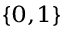<formula> <loc_0><loc_0><loc_500><loc_500>_ { \{ 0 , 1 \} }</formula> 